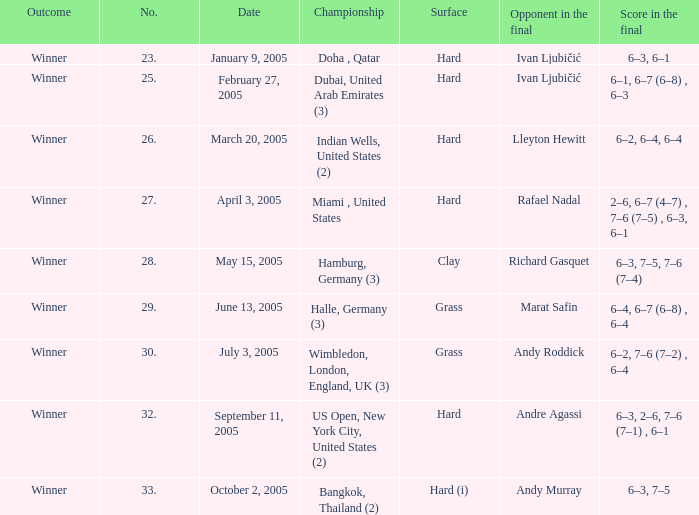How many championships exist on january 9, 2005? 1.0. 